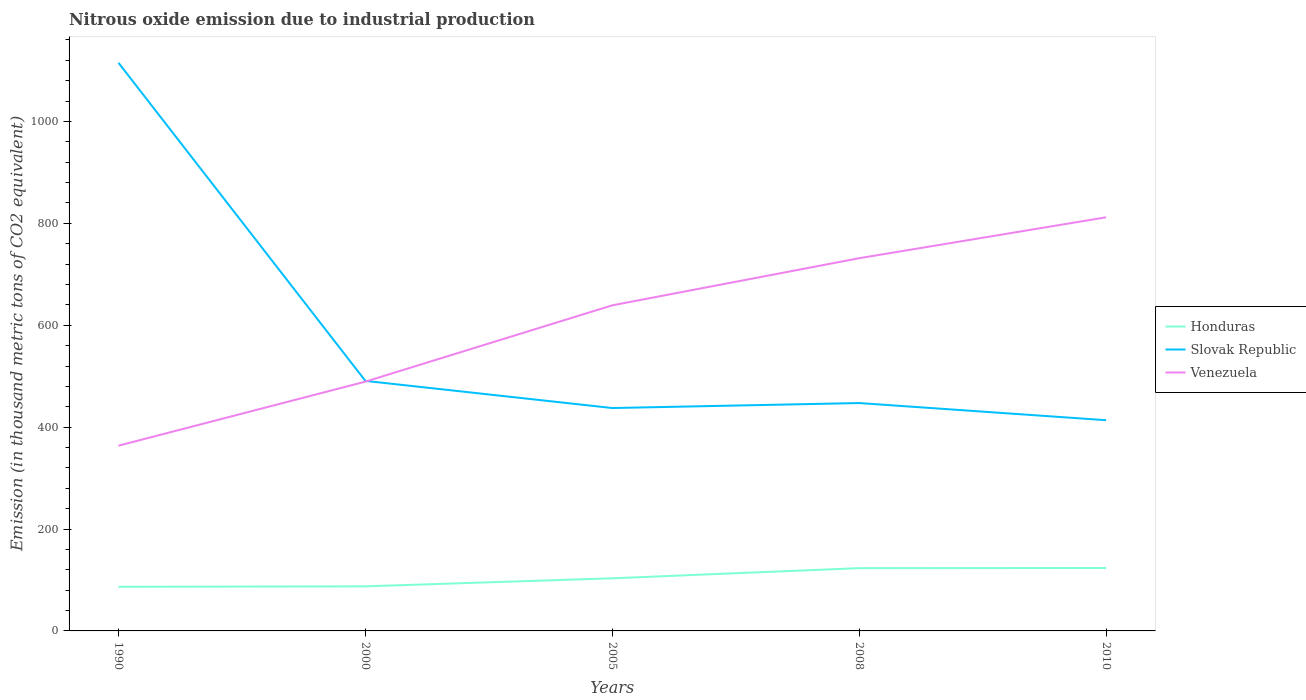How many different coloured lines are there?
Give a very brief answer. 3. Is the number of lines equal to the number of legend labels?
Keep it short and to the point. Yes. Across all years, what is the maximum amount of nitrous oxide emitted in Honduras?
Ensure brevity in your answer.  86.6. In which year was the amount of nitrous oxide emitted in Slovak Republic maximum?
Offer a very short reply. 2010. What is the total amount of nitrous oxide emitted in Venezuela in the graph?
Give a very brief answer. -125.7. What is the difference between the highest and the second highest amount of nitrous oxide emitted in Slovak Republic?
Offer a terse response. 701.6. What is the difference between the highest and the lowest amount of nitrous oxide emitted in Honduras?
Offer a terse response. 2. How many lines are there?
Keep it short and to the point. 3. What is the difference between two consecutive major ticks on the Y-axis?
Keep it short and to the point. 200. Are the values on the major ticks of Y-axis written in scientific E-notation?
Ensure brevity in your answer.  No. Does the graph contain grids?
Make the answer very short. No. Where does the legend appear in the graph?
Provide a short and direct response. Center right. How many legend labels are there?
Provide a short and direct response. 3. How are the legend labels stacked?
Provide a succinct answer. Vertical. What is the title of the graph?
Give a very brief answer. Nitrous oxide emission due to industrial production. Does "Poland" appear as one of the legend labels in the graph?
Provide a short and direct response. No. What is the label or title of the Y-axis?
Your response must be concise. Emission (in thousand metric tons of CO2 equivalent). What is the Emission (in thousand metric tons of CO2 equivalent) of Honduras in 1990?
Provide a succinct answer. 86.6. What is the Emission (in thousand metric tons of CO2 equivalent) of Slovak Republic in 1990?
Your response must be concise. 1115.2. What is the Emission (in thousand metric tons of CO2 equivalent) of Venezuela in 1990?
Keep it short and to the point. 363.6. What is the Emission (in thousand metric tons of CO2 equivalent) of Honduras in 2000?
Your answer should be very brief. 87.5. What is the Emission (in thousand metric tons of CO2 equivalent) in Slovak Republic in 2000?
Provide a short and direct response. 490.8. What is the Emission (in thousand metric tons of CO2 equivalent) of Venezuela in 2000?
Offer a very short reply. 489.3. What is the Emission (in thousand metric tons of CO2 equivalent) of Honduras in 2005?
Keep it short and to the point. 103.3. What is the Emission (in thousand metric tons of CO2 equivalent) of Slovak Republic in 2005?
Give a very brief answer. 437.5. What is the Emission (in thousand metric tons of CO2 equivalent) of Venezuela in 2005?
Keep it short and to the point. 639.1. What is the Emission (in thousand metric tons of CO2 equivalent) of Honduras in 2008?
Offer a terse response. 123.2. What is the Emission (in thousand metric tons of CO2 equivalent) of Slovak Republic in 2008?
Provide a short and direct response. 447.3. What is the Emission (in thousand metric tons of CO2 equivalent) in Venezuela in 2008?
Provide a short and direct response. 731.6. What is the Emission (in thousand metric tons of CO2 equivalent) in Honduras in 2010?
Your answer should be very brief. 123.5. What is the Emission (in thousand metric tons of CO2 equivalent) in Slovak Republic in 2010?
Offer a very short reply. 413.6. What is the Emission (in thousand metric tons of CO2 equivalent) in Venezuela in 2010?
Ensure brevity in your answer.  811.9. Across all years, what is the maximum Emission (in thousand metric tons of CO2 equivalent) in Honduras?
Your answer should be very brief. 123.5. Across all years, what is the maximum Emission (in thousand metric tons of CO2 equivalent) of Slovak Republic?
Make the answer very short. 1115.2. Across all years, what is the maximum Emission (in thousand metric tons of CO2 equivalent) in Venezuela?
Give a very brief answer. 811.9. Across all years, what is the minimum Emission (in thousand metric tons of CO2 equivalent) in Honduras?
Your response must be concise. 86.6. Across all years, what is the minimum Emission (in thousand metric tons of CO2 equivalent) in Slovak Republic?
Your response must be concise. 413.6. Across all years, what is the minimum Emission (in thousand metric tons of CO2 equivalent) of Venezuela?
Offer a very short reply. 363.6. What is the total Emission (in thousand metric tons of CO2 equivalent) of Honduras in the graph?
Provide a short and direct response. 524.1. What is the total Emission (in thousand metric tons of CO2 equivalent) of Slovak Republic in the graph?
Provide a short and direct response. 2904.4. What is the total Emission (in thousand metric tons of CO2 equivalent) of Venezuela in the graph?
Your answer should be very brief. 3035.5. What is the difference between the Emission (in thousand metric tons of CO2 equivalent) in Slovak Republic in 1990 and that in 2000?
Provide a short and direct response. 624.4. What is the difference between the Emission (in thousand metric tons of CO2 equivalent) in Venezuela in 1990 and that in 2000?
Keep it short and to the point. -125.7. What is the difference between the Emission (in thousand metric tons of CO2 equivalent) in Honduras in 1990 and that in 2005?
Your response must be concise. -16.7. What is the difference between the Emission (in thousand metric tons of CO2 equivalent) in Slovak Republic in 1990 and that in 2005?
Make the answer very short. 677.7. What is the difference between the Emission (in thousand metric tons of CO2 equivalent) in Venezuela in 1990 and that in 2005?
Your response must be concise. -275.5. What is the difference between the Emission (in thousand metric tons of CO2 equivalent) in Honduras in 1990 and that in 2008?
Give a very brief answer. -36.6. What is the difference between the Emission (in thousand metric tons of CO2 equivalent) in Slovak Republic in 1990 and that in 2008?
Offer a terse response. 667.9. What is the difference between the Emission (in thousand metric tons of CO2 equivalent) in Venezuela in 1990 and that in 2008?
Keep it short and to the point. -368. What is the difference between the Emission (in thousand metric tons of CO2 equivalent) in Honduras in 1990 and that in 2010?
Keep it short and to the point. -36.9. What is the difference between the Emission (in thousand metric tons of CO2 equivalent) in Slovak Republic in 1990 and that in 2010?
Your answer should be compact. 701.6. What is the difference between the Emission (in thousand metric tons of CO2 equivalent) of Venezuela in 1990 and that in 2010?
Your answer should be compact. -448.3. What is the difference between the Emission (in thousand metric tons of CO2 equivalent) in Honduras in 2000 and that in 2005?
Make the answer very short. -15.8. What is the difference between the Emission (in thousand metric tons of CO2 equivalent) of Slovak Republic in 2000 and that in 2005?
Your answer should be compact. 53.3. What is the difference between the Emission (in thousand metric tons of CO2 equivalent) in Venezuela in 2000 and that in 2005?
Offer a terse response. -149.8. What is the difference between the Emission (in thousand metric tons of CO2 equivalent) in Honduras in 2000 and that in 2008?
Make the answer very short. -35.7. What is the difference between the Emission (in thousand metric tons of CO2 equivalent) in Slovak Republic in 2000 and that in 2008?
Keep it short and to the point. 43.5. What is the difference between the Emission (in thousand metric tons of CO2 equivalent) of Venezuela in 2000 and that in 2008?
Make the answer very short. -242.3. What is the difference between the Emission (in thousand metric tons of CO2 equivalent) in Honduras in 2000 and that in 2010?
Make the answer very short. -36. What is the difference between the Emission (in thousand metric tons of CO2 equivalent) in Slovak Republic in 2000 and that in 2010?
Provide a short and direct response. 77.2. What is the difference between the Emission (in thousand metric tons of CO2 equivalent) in Venezuela in 2000 and that in 2010?
Give a very brief answer. -322.6. What is the difference between the Emission (in thousand metric tons of CO2 equivalent) in Honduras in 2005 and that in 2008?
Offer a very short reply. -19.9. What is the difference between the Emission (in thousand metric tons of CO2 equivalent) in Slovak Republic in 2005 and that in 2008?
Provide a succinct answer. -9.8. What is the difference between the Emission (in thousand metric tons of CO2 equivalent) of Venezuela in 2005 and that in 2008?
Your answer should be compact. -92.5. What is the difference between the Emission (in thousand metric tons of CO2 equivalent) in Honduras in 2005 and that in 2010?
Give a very brief answer. -20.2. What is the difference between the Emission (in thousand metric tons of CO2 equivalent) in Slovak Republic in 2005 and that in 2010?
Your response must be concise. 23.9. What is the difference between the Emission (in thousand metric tons of CO2 equivalent) in Venezuela in 2005 and that in 2010?
Offer a very short reply. -172.8. What is the difference between the Emission (in thousand metric tons of CO2 equivalent) in Honduras in 2008 and that in 2010?
Ensure brevity in your answer.  -0.3. What is the difference between the Emission (in thousand metric tons of CO2 equivalent) of Slovak Republic in 2008 and that in 2010?
Give a very brief answer. 33.7. What is the difference between the Emission (in thousand metric tons of CO2 equivalent) of Venezuela in 2008 and that in 2010?
Your answer should be very brief. -80.3. What is the difference between the Emission (in thousand metric tons of CO2 equivalent) in Honduras in 1990 and the Emission (in thousand metric tons of CO2 equivalent) in Slovak Republic in 2000?
Your answer should be compact. -404.2. What is the difference between the Emission (in thousand metric tons of CO2 equivalent) in Honduras in 1990 and the Emission (in thousand metric tons of CO2 equivalent) in Venezuela in 2000?
Make the answer very short. -402.7. What is the difference between the Emission (in thousand metric tons of CO2 equivalent) in Slovak Republic in 1990 and the Emission (in thousand metric tons of CO2 equivalent) in Venezuela in 2000?
Offer a very short reply. 625.9. What is the difference between the Emission (in thousand metric tons of CO2 equivalent) of Honduras in 1990 and the Emission (in thousand metric tons of CO2 equivalent) of Slovak Republic in 2005?
Offer a terse response. -350.9. What is the difference between the Emission (in thousand metric tons of CO2 equivalent) in Honduras in 1990 and the Emission (in thousand metric tons of CO2 equivalent) in Venezuela in 2005?
Offer a very short reply. -552.5. What is the difference between the Emission (in thousand metric tons of CO2 equivalent) in Slovak Republic in 1990 and the Emission (in thousand metric tons of CO2 equivalent) in Venezuela in 2005?
Keep it short and to the point. 476.1. What is the difference between the Emission (in thousand metric tons of CO2 equivalent) of Honduras in 1990 and the Emission (in thousand metric tons of CO2 equivalent) of Slovak Republic in 2008?
Your answer should be very brief. -360.7. What is the difference between the Emission (in thousand metric tons of CO2 equivalent) of Honduras in 1990 and the Emission (in thousand metric tons of CO2 equivalent) of Venezuela in 2008?
Provide a short and direct response. -645. What is the difference between the Emission (in thousand metric tons of CO2 equivalent) of Slovak Republic in 1990 and the Emission (in thousand metric tons of CO2 equivalent) of Venezuela in 2008?
Your answer should be very brief. 383.6. What is the difference between the Emission (in thousand metric tons of CO2 equivalent) in Honduras in 1990 and the Emission (in thousand metric tons of CO2 equivalent) in Slovak Republic in 2010?
Offer a terse response. -327. What is the difference between the Emission (in thousand metric tons of CO2 equivalent) in Honduras in 1990 and the Emission (in thousand metric tons of CO2 equivalent) in Venezuela in 2010?
Your response must be concise. -725.3. What is the difference between the Emission (in thousand metric tons of CO2 equivalent) in Slovak Republic in 1990 and the Emission (in thousand metric tons of CO2 equivalent) in Venezuela in 2010?
Give a very brief answer. 303.3. What is the difference between the Emission (in thousand metric tons of CO2 equivalent) in Honduras in 2000 and the Emission (in thousand metric tons of CO2 equivalent) in Slovak Republic in 2005?
Your answer should be compact. -350. What is the difference between the Emission (in thousand metric tons of CO2 equivalent) in Honduras in 2000 and the Emission (in thousand metric tons of CO2 equivalent) in Venezuela in 2005?
Give a very brief answer. -551.6. What is the difference between the Emission (in thousand metric tons of CO2 equivalent) in Slovak Republic in 2000 and the Emission (in thousand metric tons of CO2 equivalent) in Venezuela in 2005?
Offer a very short reply. -148.3. What is the difference between the Emission (in thousand metric tons of CO2 equivalent) in Honduras in 2000 and the Emission (in thousand metric tons of CO2 equivalent) in Slovak Republic in 2008?
Offer a terse response. -359.8. What is the difference between the Emission (in thousand metric tons of CO2 equivalent) of Honduras in 2000 and the Emission (in thousand metric tons of CO2 equivalent) of Venezuela in 2008?
Give a very brief answer. -644.1. What is the difference between the Emission (in thousand metric tons of CO2 equivalent) of Slovak Republic in 2000 and the Emission (in thousand metric tons of CO2 equivalent) of Venezuela in 2008?
Ensure brevity in your answer.  -240.8. What is the difference between the Emission (in thousand metric tons of CO2 equivalent) of Honduras in 2000 and the Emission (in thousand metric tons of CO2 equivalent) of Slovak Republic in 2010?
Your answer should be compact. -326.1. What is the difference between the Emission (in thousand metric tons of CO2 equivalent) of Honduras in 2000 and the Emission (in thousand metric tons of CO2 equivalent) of Venezuela in 2010?
Keep it short and to the point. -724.4. What is the difference between the Emission (in thousand metric tons of CO2 equivalent) of Slovak Republic in 2000 and the Emission (in thousand metric tons of CO2 equivalent) of Venezuela in 2010?
Ensure brevity in your answer.  -321.1. What is the difference between the Emission (in thousand metric tons of CO2 equivalent) of Honduras in 2005 and the Emission (in thousand metric tons of CO2 equivalent) of Slovak Republic in 2008?
Give a very brief answer. -344. What is the difference between the Emission (in thousand metric tons of CO2 equivalent) in Honduras in 2005 and the Emission (in thousand metric tons of CO2 equivalent) in Venezuela in 2008?
Offer a terse response. -628.3. What is the difference between the Emission (in thousand metric tons of CO2 equivalent) in Slovak Republic in 2005 and the Emission (in thousand metric tons of CO2 equivalent) in Venezuela in 2008?
Your answer should be compact. -294.1. What is the difference between the Emission (in thousand metric tons of CO2 equivalent) in Honduras in 2005 and the Emission (in thousand metric tons of CO2 equivalent) in Slovak Republic in 2010?
Your answer should be compact. -310.3. What is the difference between the Emission (in thousand metric tons of CO2 equivalent) in Honduras in 2005 and the Emission (in thousand metric tons of CO2 equivalent) in Venezuela in 2010?
Your answer should be very brief. -708.6. What is the difference between the Emission (in thousand metric tons of CO2 equivalent) in Slovak Republic in 2005 and the Emission (in thousand metric tons of CO2 equivalent) in Venezuela in 2010?
Offer a terse response. -374.4. What is the difference between the Emission (in thousand metric tons of CO2 equivalent) in Honduras in 2008 and the Emission (in thousand metric tons of CO2 equivalent) in Slovak Republic in 2010?
Give a very brief answer. -290.4. What is the difference between the Emission (in thousand metric tons of CO2 equivalent) of Honduras in 2008 and the Emission (in thousand metric tons of CO2 equivalent) of Venezuela in 2010?
Provide a succinct answer. -688.7. What is the difference between the Emission (in thousand metric tons of CO2 equivalent) in Slovak Republic in 2008 and the Emission (in thousand metric tons of CO2 equivalent) in Venezuela in 2010?
Offer a terse response. -364.6. What is the average Emission (in thousand metric tons of CO2 equivalent) in Honduras per year?
Keep it short and to the point. 104.82. What is the average Emission (in thousand metric tons of CO2 equivalent) of Slovak Republic per year?
Provide a short and direct response. 580.88. What is the average Emission (in thousand metric tons of CO2 equivalent) in Venezuela per year?
Offer a very short reply. 607.1. In the year 1990, what is the difference between the Emission (in thousand metric tons of CO2 equivalent) of Honduras and Emission (in thousand metric tons of CO2 equivalent) of Slovak Republic?
Keep it short and to the point. -1028.6. In the year 1990, what is the difference between the Emission (in thousand metric tons of CO2 equivalent) of Honduras and Emission (in thousand metric tons of CO2 equivalent) of Venezuela?
Your response must be concise. -277. In the year 1990, what is the difference between the Emission (in thousand metric tons of CO2 equivalent) of Slovak Republic and Emission (in thousand metric tons of CO2 equivalent) of Venezuela?
Provide a succinct answer. 751.6. In the year 2000, what is the difference between the Emission (in thousand metric tons of CO2 equivalent) in Honduras and Emission (in thousand metric tons of CO2 equivalent) in Slovak Republic?
Ensure brevity in your answer.  -403.3. In the year 2000, what is the difference between the Emission (in thousand metric tons of CO2 equivalent) in Honduras and Emission (in thousand metric tons of CO2 equivalent) in Venezuela?
Ensure brevity in your answer.  -401.8. In the year 2005, what is the difference between the Emission (in thousand metric tons of CO2 equivalent) of Honduras and Emission (in thousand metric tons of CO2 equivalent) of Slovak Republic?
Offer a very short reply. -334.2. In the year 2005, what is the difference between the Emission (in thousand metric tons of CO2 equivalent) of Honduras and Emission (in thousand metric tons of CO2 equivalent) of Venezuela?
Ensure brevity in your answer.  -535.8. In the year 2005, what is the difference between the Emission (in thousand metric tons of CO2 equivalent) of Slovak Republic and Emission (in thousand metric tons of CO2 equivalent) of Venezuela?
Your answer should be compact. -201.6. In the year 2008, what is the difference between the Emission (in thousand metric tons of CO2 equivalent) in Honduras and Emission (in thousand metric tons of CO2 equivalent) in Slovak Republic?
Provide a succinct answer. -324.1. In the year 2008, what is the difference between the Emission (in thousand metric tons of CO2 equivalent) of Honduras and Emission (in thousand metric tons of CO2 equivalent) of Venezuela?
Ensure brevity in your answer.  -608.4. In the year 2008, what is the difference between the Emission (in thousand metric tons of CO2 equivalent) of Slovak Republic and Emission (in thousand metric tons of CO2 equivalent) of Venezuela?
Offer a terse response. -284.3. In the year 2010, what is the difference between the Emission (in thousand metric tons of CO2 equivalent) of Honduras and Emission (in thousand metric tons of CO2 equivalent) of Slovak Republic?
Provide a short and direct response. -290.1. In the year 2010, what is the difference between the Emission (in thousand metric tons of CO2 equivalent) in Honduras and Emission (in thousand metric tons of CO2 equivalent) in Venezuela?
Offer a terse response. -688.4. In the year 2010, what is the difference between the Emission (in thousand metric tons of CO2 equivalent) of Slovak Republic and Emission (in thousand metric tons of CO2 equivalent) of Venezuela?
Your response must be concise. -398.3. What is the ratio of the Emission (in thousand metric tons of CO2 equivalent) of Slovak Republic in 1990 to that in 2000?
Offer a terse response. 2.27. What is the ratio of the Emission (in thousand metric tons of CO2 equivalent) in Venezuela in 1990 to that in 2000?
Make the answer very short. 0.74. What is the ratio of the Emission (in thousand metric tons of CO2 equivalent) in Honduras in 1990 to that in 2005?
Provide a succinct answer. 0.84. What is the ratio of the Emission (in thousand metric tons of CO2 equivalent) in Slovak Republic in 1990 to that in 2005?
Your answer should be compact. 2.55. What is the ratio of the Emission (in thousand metric tons of CO2 equivalent) in Venezuela in 1990 to that in 2005?
Give a very brief answer. 0.57. What is the ratio of the Emission (in thousand metric tons of CO2 equivalent) in Honduras in 1990 to that in 2008?
Provide a short and direct response. 0.7. What is the ratio of the Emission (in thousand metric tons of CO2 equivalent) of Slovak Republic in 1990 to that in 2008?
Offer a terse response. 2.49. What is the ratio of the Emission (in thousand metric tons of CO2 equivalent) of Venezuela in 1990 to that in 2008?
Provide a short and direct response. 0.5. What is the ratio of the Emission (in thousand metric tons of CO2 equivalent) in Honduras in 1990 to that in 2010?
Give a very brief answer. 0.7. What is the ratio of the Emission (in thousand metric tons of CO2 equivalent) of Slovak Republic in 1990 to that in 2010?
Ensure brevity in your answer.  2.7. What is the ratio of the Emission (in thousand metric tons of CO2 equivalent) in Venezuela in 1990 to that in 2010?
Keep it short and to the point. 0.45. What is the ratio of the Emission (in thousand metric tons of CO2 equivalent) of Honduras in 2000 to that in 2005?
Ensure brevity in your answer.  0.85. What is the ratio of the Emission (in thousand metric tons of CO2 equivalent) in Slovak Republic in 2000 to that in 2005?
Your response must be concise. 1.12. What is the ratio of the Emission (in thousand metric tons of CO2 equivalent) of Venezuela in 2000 to that in 2005?
Your response must be concise. 0.77. What is the ratio of the Emission (in thousand metric tons of CO2 equivalent) of Honduras in 2000 to that in 2008?
Your answer should be very brief. 0.71. What is the ratio of the Emission (in thousand metric tons of CO2 equivalent) of Slovak Republic in 2000 to that in 2008?
Your response must be concise. 1.1. What is the ratio of the Emission (in thousand metric tons of CO2 equivalent) of Venezuela in 2000 to that in 2008?
Your answer should be very brief. 0.67. What is the ratio of the Emission (in thousand metric tons of CO2 equivalent) of Honduras in 2000 to that in 2010?
Ensure brevity in your answer.  0.71. What is the ratio of the Emission (in thousand metric tons of CO2 equivalent) of Slovak Republic in 2000 to that in 2010?
Offer a very short reply. 1.19. What is the ratio of the Emission (in thousand metric tons of CO2 equivalent) in Venezuela in 2000 to that in 2010?
Your response must be concise. 0.6. What is the ratio of the Emission (in thousand metric tons of CO2 equivalent) in Honduras in 2005 to that in 2008?
Give a very brief answer. 0.84. What is the ratio of the Emission (in thousand metric tons of CO2 equivalent) in Slovak Republic in 2005 to that in 2008?
Offer a very short reply. 0.98. What is the ratio of the Emission (in thousand metric tons of CO2 equivalent) in Venezuela in 2005 to that in 2008?
Offer a very short reply. 0.87. What is the ratio of the Emission (in thousand metric tons of CO2 equivalent) of Honduras in 2005 to that in 2010?
Keep it short and to the point. 0.84. What is the ratio of the Emission (in thousand metric tons of CO2 equivalent) in Slovak Republic in 2005 to that in 2010?
Offer a very short reply. 1.06. What is the ratio of the Emission (in thousand metric tons of CO2 equivalent) in Venezuela in 2005 to that in 2010?
Your answer should be compact. 0.79. What is the ratio of the Emission (in thousand metric tons of CO2 equivalent) of Honduras in 2008 to that in 2010?
Offer a terse response. 1. What is the ratio of the Emission (in thousand metric tons of CO2 equivalent) in Slovak Republic in 2008 to that in 2010?
Provide a succinct answer. 1.08. What is the ratio of the Emission (in thousand metric tons of CO2 equivalent) in Venezuela in 2008 to that in 2010?
Provide a succinct answer. 0.9. What is the difference between the highest and the second highest Emission (in thousand metric tons of CO2 equivalent) of Slovak Republic?
Your answer should be very brief. 624.4. What is the difference between the highest and the second highest Emission (in thousand metric tons of CO2 equivalent) of Venezuela?
Offer a very short reply. 80.3. What is the difference between the highest and the lowest Emission (in thousand metric tons of CO2 equivalent) in Honduras?
Keep it short and to the point. 36.9. What is the difference between the highest and the lowest Emission (in thousand metric tons of CO2 equivalent) in Slovak Republic?
Offer a very short reply. 701.6. What is the difference between the highest and the lowest Emission (in thousand metric tons of CO2 equivalent) of Venezuela?
Your answer should be compact. 448.3. 